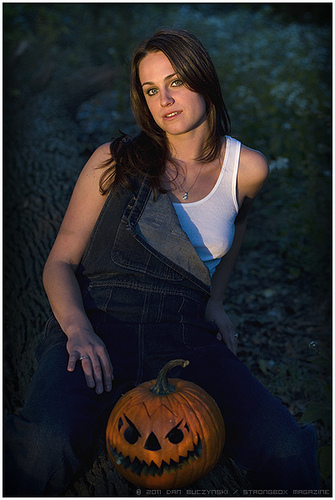<image>
Is there a pumpkin under the woman? Yes. The pumpkin is positioned underneath the woman, with the woman above it in the vertical space. 